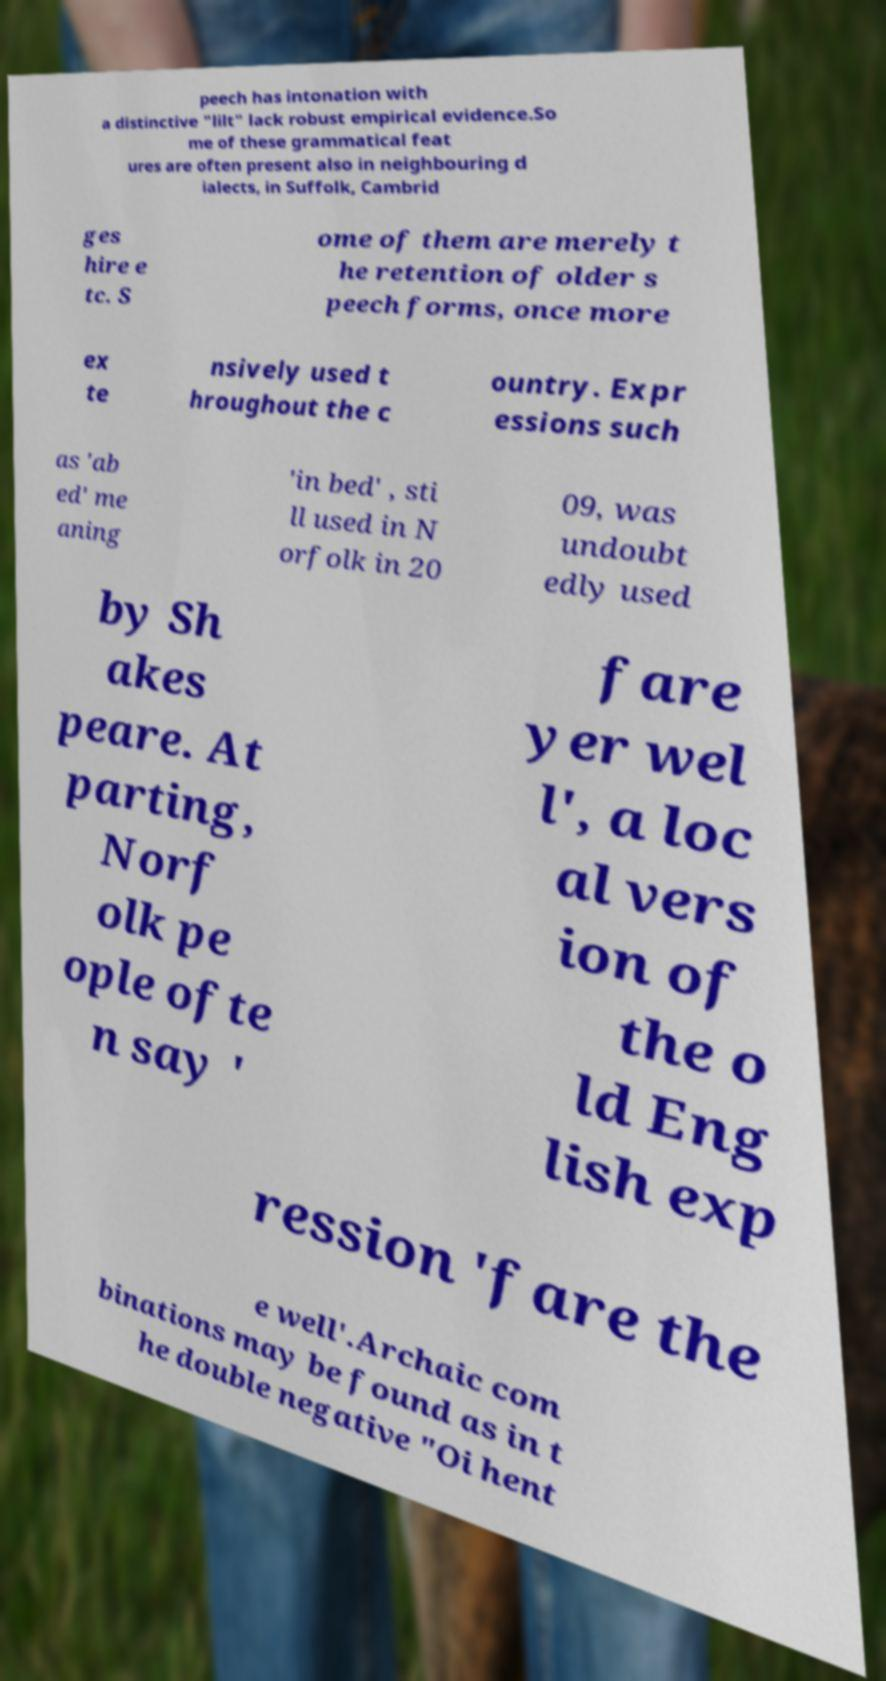Can you read and provide the text displayed in the image?This photo seems to have some interesting text. Can you extract and type it out for me? peech has intonation with a distinctive "lilt" lack robust empirical evidence.So me of these grammatical feat ures are often present also in neighbouring d ialects, in Suffolk, Cambrid ges hire e tc. S ome of them are merely t he retention of older s peech forms, once more ex te nsively used t hroughout the c ountry. Expr essions such as 'ab ed' me aning 'in bed' , sti ll used in N orfolk in 20 09, was undoubt edly used by Sh akes peare. At parting, Norf olk pe ople ofte n say ' fare yer wel l', a loc al vers ion of the o ld Eng lish exp ression 'fare the e well'.Archaic com binations may be found as in t he double negative "Oi hent 